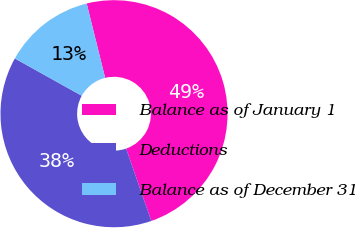<chart> <loc_0><loc_0><loc_500><loc_500><pie_chart><fcel>Balance as of January 1<fcel>Deductions<fcel>Balance as of December 31<nl><fcel>48.55%<fcel>38.41%<fcel>13.04%<nl></chart> 